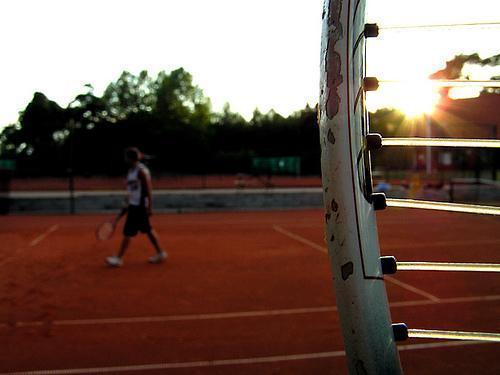What is partially blocking this image?
Choose the right answer from the provided options to respond to the question.
Options: Fan, spokes, racket, tubing. Racket. 